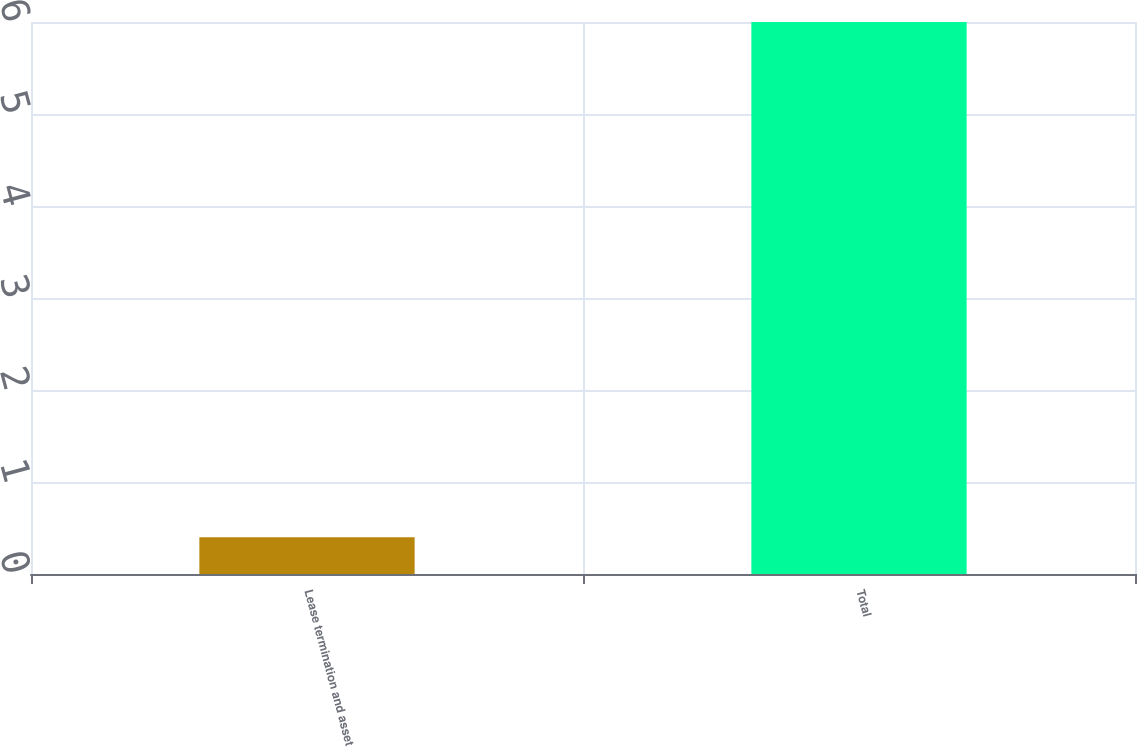<chart> <loc_0><loc_0><loc_500><loc_500><bar_chart><fcel>Lease termination and asset<fcel>Total<nl><fcel>0.4<fcel>6<nl></chart> 